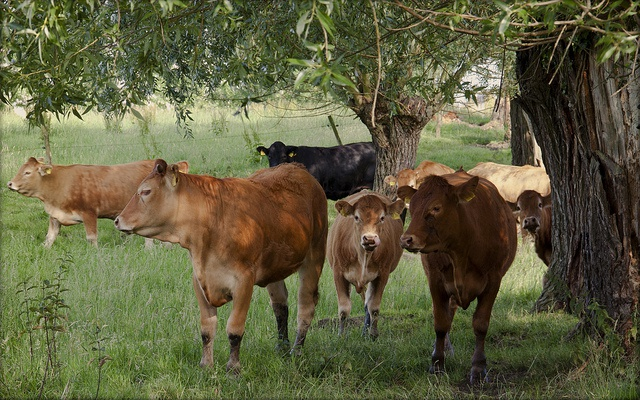Describe the objects in this image and their specific colors. I can see cow in black, maroon, and gray tones, cow in black, maroon, and gray tones, cow in black, gray, tan, olive, and brown tones, cow in black, maroon, and gray tones, and cow in black and gray tones in this image. 